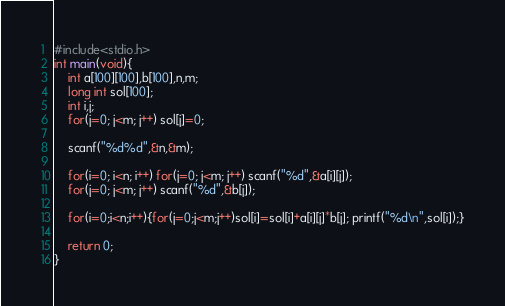Convert code to text. <code><loc_0><loc_0><loc_500><loc_500><_C_>#include<stdio.h>
int main(void){
	int a[100][100],b[100],n,m;
	long int sol[100];
	int i,j;
	for(j=0; j<m; j++) sol[j]=0;

	scanf("%d%d",&n,&m);
	
	for(i=0; i<n; i++) for(j=0; j<m; j++) scanf("%d",&a[i][j]);
	for(j=0; j<m; j++) scanf("%d",&b[j]);
	
	for(i=0;i<n;i++){for(j=0;j<m;j++)sol[i]=sol[i]+a[i][j]*b[j]; printf("%d\n",sol[i]);}
	
	return 0;
}</code> 